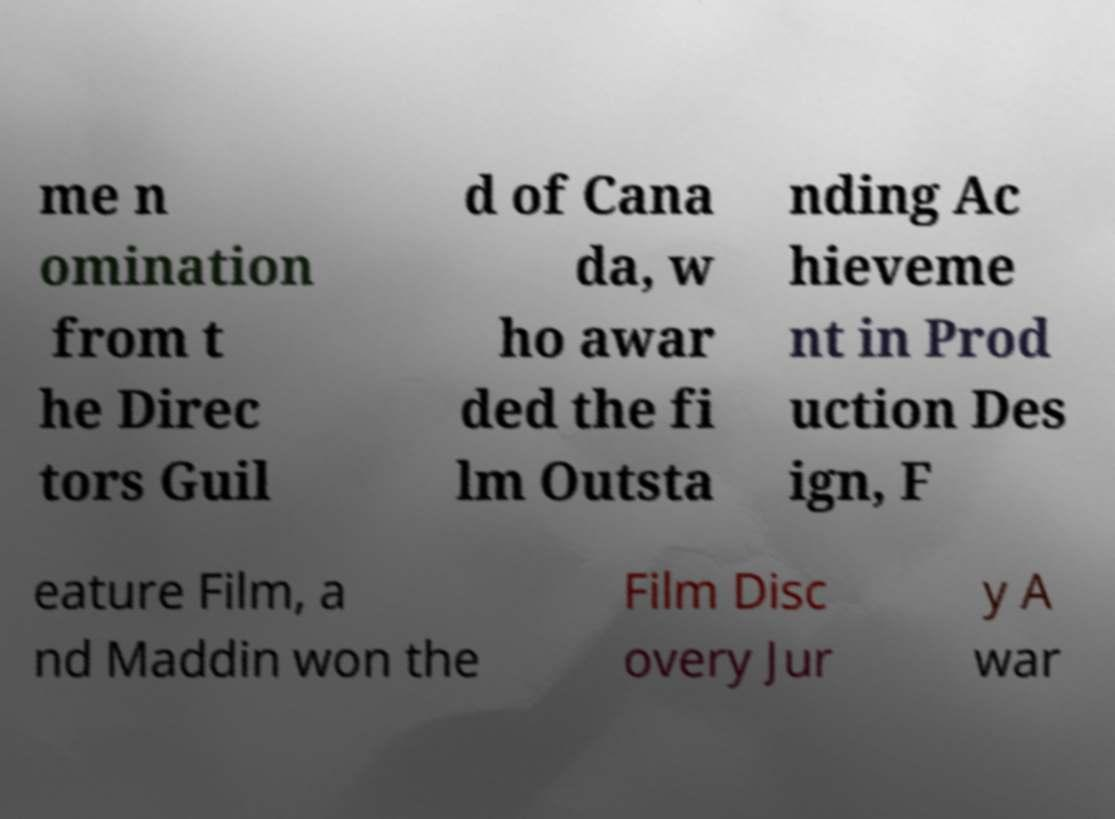Please read and relay the text visible in this image. What does it say? me n omination from t he Direc tors Guil d of Cana da, w ho awar ded the fi lm Outsta nding Ac hieveme nt in Prod uction Des ign, F eature Film, a nd Maddin won the Film Disc overy Jur y A war 